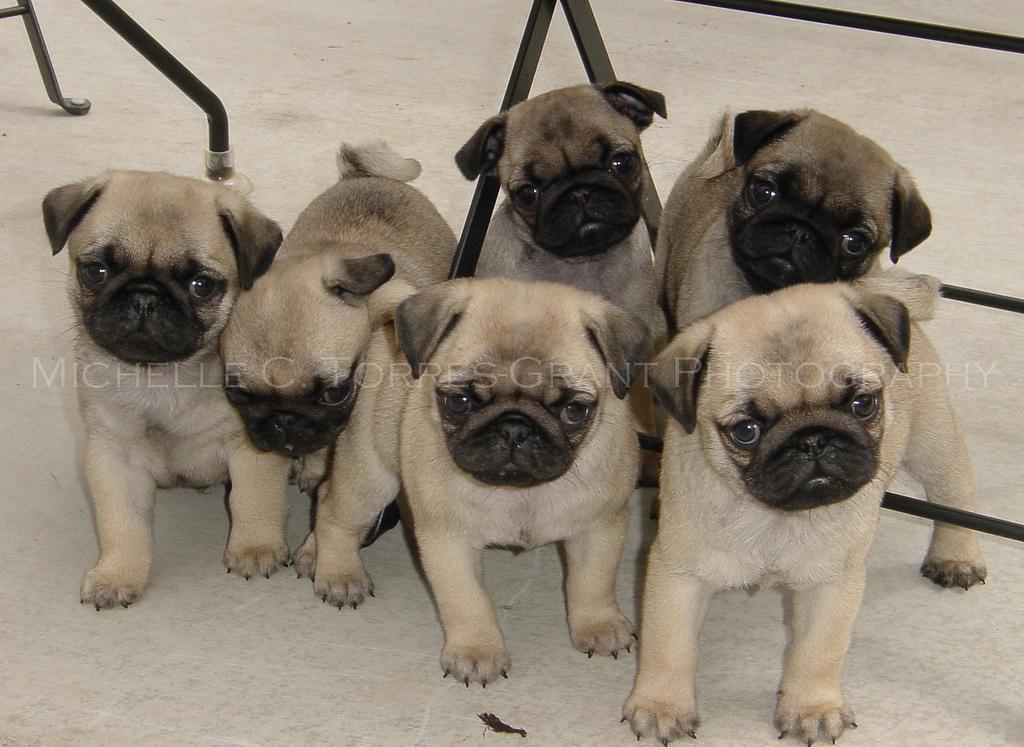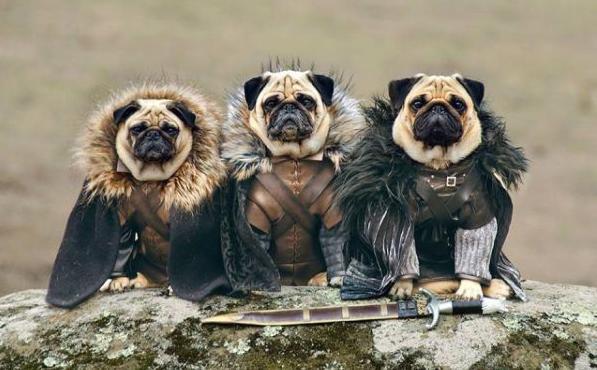The first image is the image on the left, the second image is the image on the right. For the images shown, is this caption "There are exactly three dogs in the image on the right." true? Answer yes or no. Yes. 